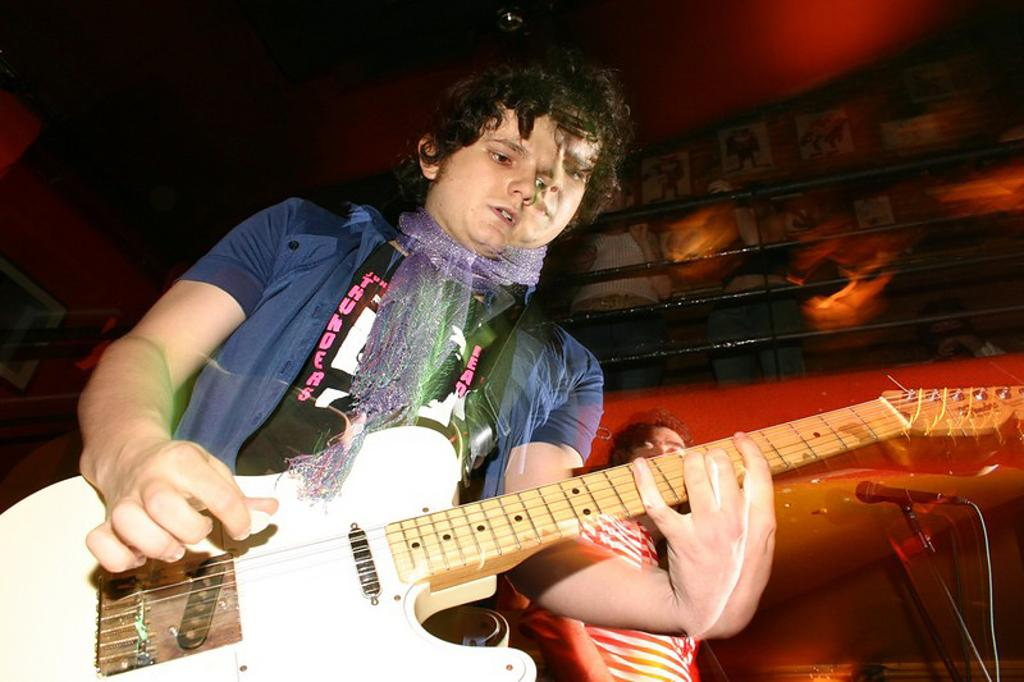What is the person in the image doing? The person is holding a guitar. What color is the shirt the person is wearing? The person is wearing a blue color shirt. What other object is present in the image related to music? There is a microphone in the image. How many fingers does the person's father have in the image? There is no person's father present in the image, and therefore no fingers to count. 